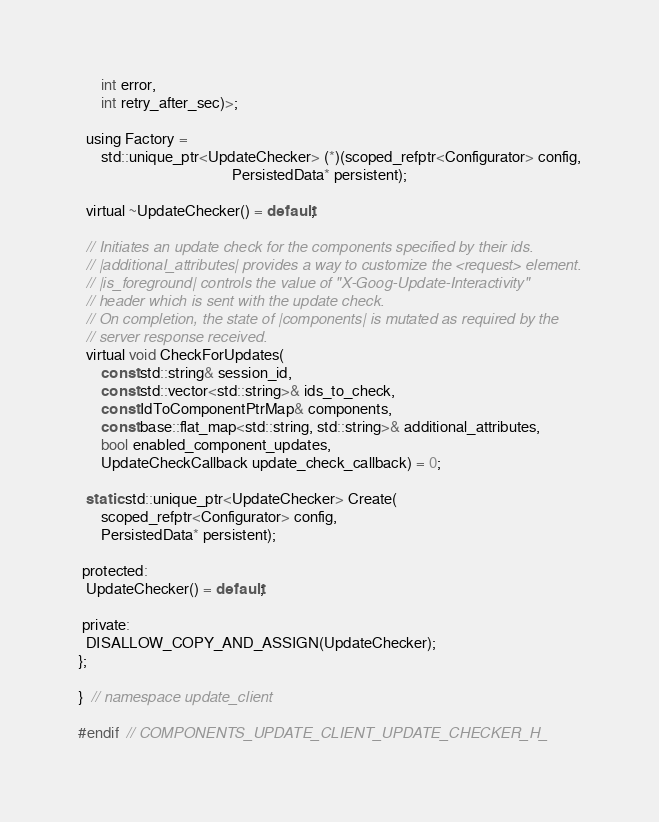<code> <loc_0><loc_0><loc_500><loc_500><_C_>      int error,
      int retry_after_sec)>;

  using Factory =
      std::unique_ptr<UpdateChecker> (*)(scoped_refptr<Configurator> config,
                                         PersistedData* persistent);

  virtual ~UpdateChecker() = default;

  // Initiates an update check for the components specified by their ids.
  // |additional_attributes| provides a way to customize the <request> element.
  // |is_foreground| controls the value of "X-Goog-Update-Interactivity"
  // header which is sent with the update check.
  // On completion, the state of |components| is mutated as required by the
  // server response received.
  virtual void CheckForUpdates(
      const std::string& session_id,
      const std::vector<std::string>& ids_to_check,
      const IdToComponentPtrMap& components,
      const base::flat_map<std::string, std::string>& additional_attributes,
      bool enabled_component_updates,
      UpdateCheckCallback update_check_callback) = 0;

  static std::unique_ptr<UpdateChecker> Create(
      scoped_refptr<Configurator> config,
      PersistedData* persistent);

 protected:
  UpdateChecker() = default;

 private:
  DISALLOW_COPY_AND_ASSIGN(UpdateChecker);
};

}  // namespace update_client

#endif  // COMPONENTS_UPDATE_CLIENT_UPDATE_CHECKER_H_
</code> 